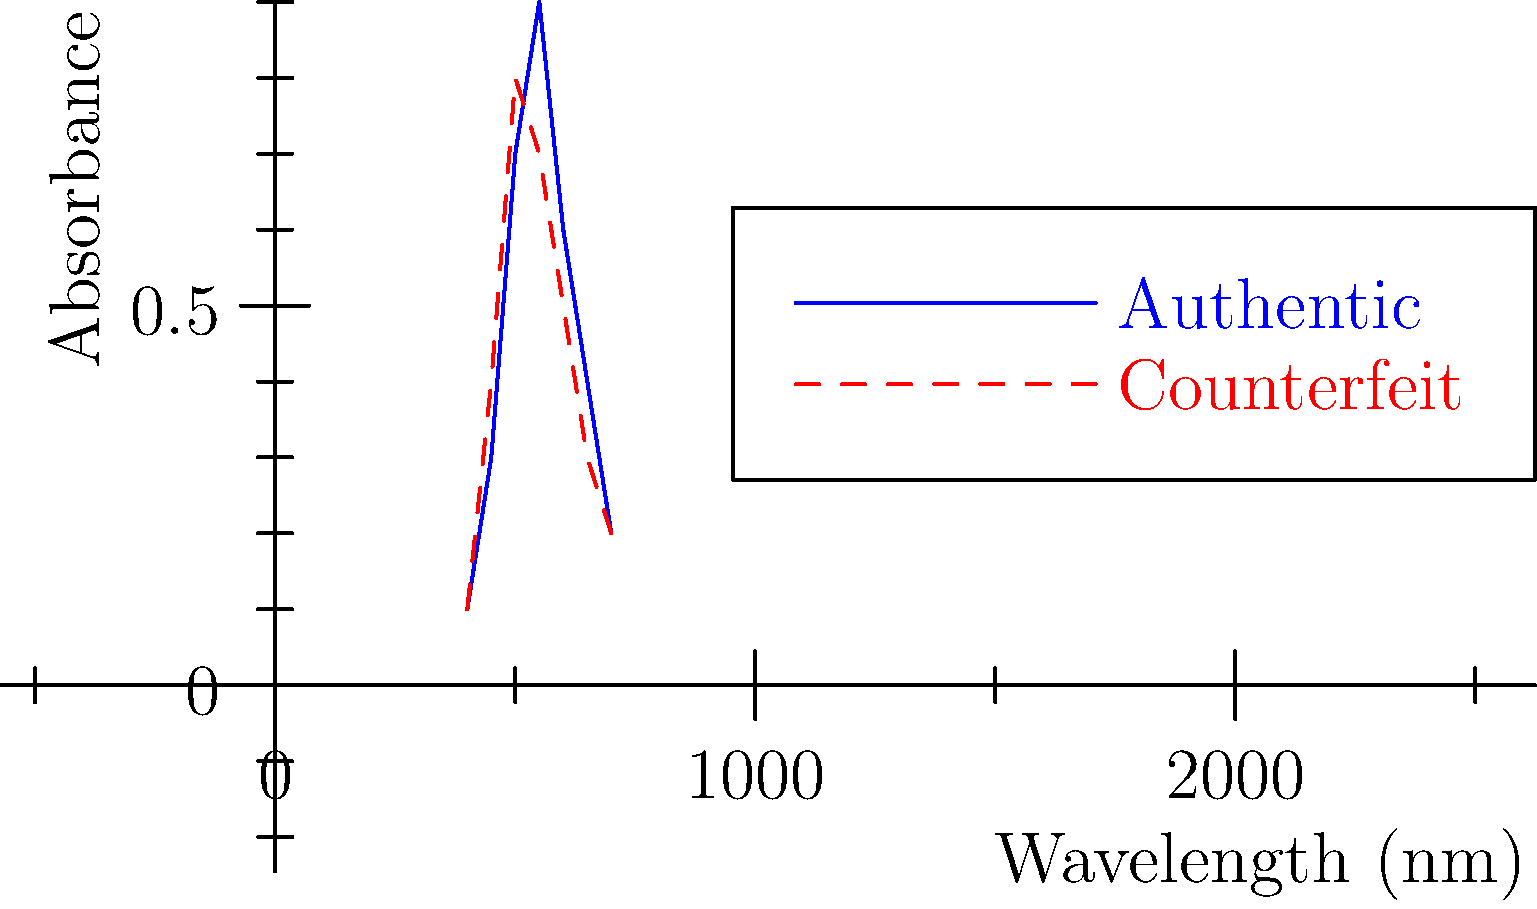Based on the spectroscopy graph, which of the following statements is most accurate in distinguishing the counterfeit medication from the authentic one?
A) The counterfeit medication has a higher absorbance peak
B) The authentic medication has a sharper absorbance peak
C) The counterfeit medication's peak is shifted to a lower wavelength
D) There is no significant difference between the two spectra To answer this question, we need to analyze the spectroscopy graph systematically:

1. Identify the curves: The blue solid line represents the authentic medication, while the red dashed line represents the counterfeit medication.

2. Compare peak heights: The authentic medication (blue) has a higher maximum absorbance (approximately 0.9) compared to the counterfeit (red) (approximately 0.8). This eliminates option A.

3. Examine peak sharpness: The authentic medication's peak is indeed sharper and more defined than the counterfeit's. This supports option B.

4. Analyze peak positions: Both peaks occur at approximately the same wavelength (550 nm). There is no significant shift in the counterfeit's peak position. This eliminates option C.

5. Overall comparison: There are clear differences between the two spectra, particularly in the peak height and sharpness. This eliminates option D.

Based on this analysis, the most accurate statement is that the authentic medication has a sharper absorbance peak. This characteristic is often used in spectroscopy to identify pure substances, as impurities or differences in molecular structure can lead to broader, less defined peaks.
Answer: B) The authentic medication has a sharper absorbance peak 